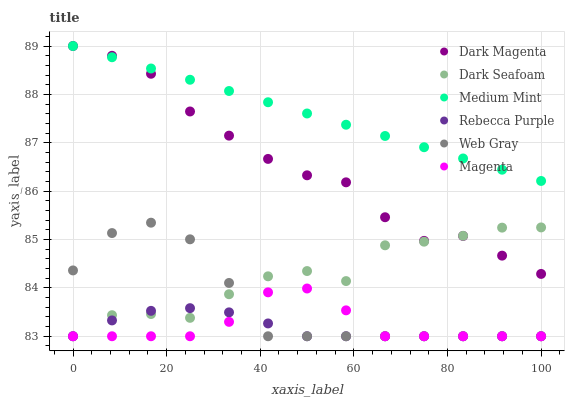Does Rebecca Purple have the minimum area under the curve?
Answer yes or no. Yes. Does Medium Mint have the maximum area under the curve?
Answer yes or no. Yes. Does Web Gray have the minimum area under the curve?
Answer yes or no. No. Does Web Gray have the maximum area under the curve?
Answer yes or no. No. Is Medium Mint the smoothest?
Answer yes or no. Yes. Is Dark Seafoam the roughest?
Answer yes or no. Yes. Is Web Gray the smoothest?
Answer yes or no. No. Is Web Gray the roughest?
Answer yes or no. No. Does Web Gray have the lowest value?
Answer yes or no. Yes. Does Dark Magenta have the lowest value?
Answer yes or no. No. Does Dark Magenta have the highest value?
Answer yes or no. Yes. Does Web Gray have the highest value?
Answer yes or no. No. Is Magenta less than Dark Magenta?
Answer yes or no. Yes. Is Medium Mint greater than Magenta?
Answer yes or no. Yes. Does Dark Seafoam intersect Dark Magenta?
Answer yes or no. Yes. Is Dark Seafoam less than Dark Magenta?
Answer yes or no. No. Is Dark Seafoam greater than Dark Magenta?
Answer yes or no. No. Does Magenta intersect Dark Magenta?
Answer yes or no. No. 